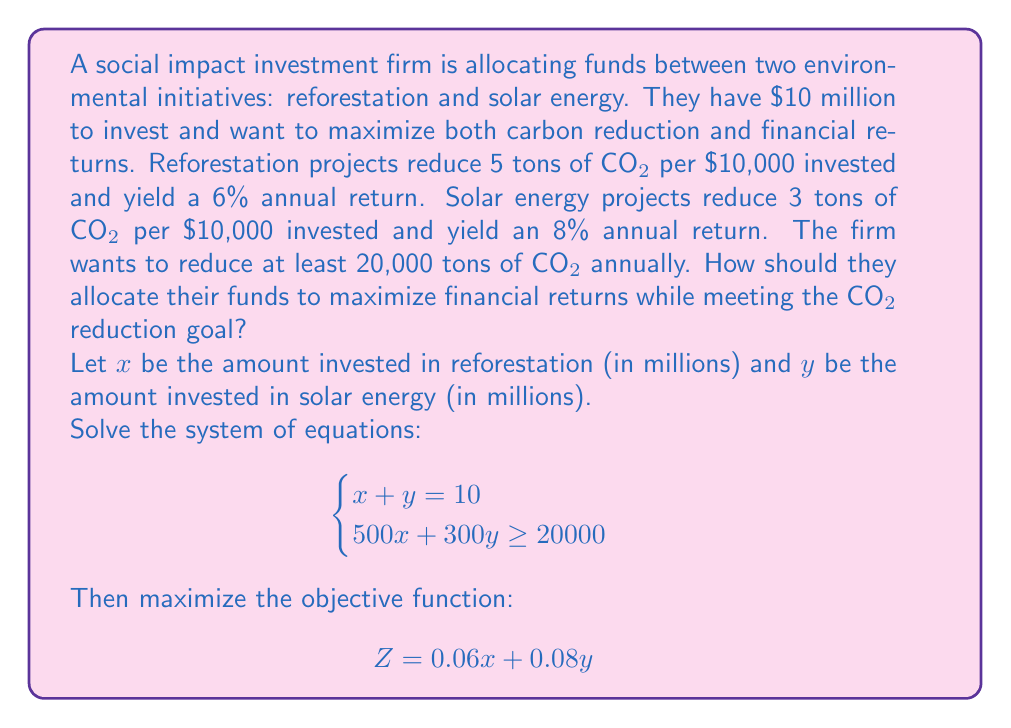Teach me how to tackle this problem. Let's approach this step-by-step:

1) First, we need to understand our constraints:
   - Total investment: $x + y = 10$
   - CO2 reduction: $500x + 300y \geq 20000$

2) We can graph these constraints:
   - The first equation is a straight line
   - The second inequality is a half-plane

3) The feasible region is the area that satisfies both constraints. The optimal solution will be at one of the corner points of this region.

4) To find the corner points, we solve the system of equations:
   $$\begin{cases}
   x + y = 10 \\
   500x + 300y = 20000
   \end{cases}$$

5) Multiply the first equation by 300:
   $$\begin{cases}
   300x + 300y = 3000 \\
   500x + 300y = 20000
   \end{cases}$$

6) Subtract the first equation from the second:
   $$200x = 17000$$
   $$x = 85/2 = 42.5$$

7) Substitute this value of $x$ into $x + y = 10$:
   $$42.5 + y = 10$$
   $$y = -32.5$$

8) However, $y$ cannot be negative. This means the optimal solution is at the intersection of $x + y = 10$ and $y = 0$, i.e., $(10, 0)$.

9) The other corner point is $(0, 10)$, but this doesn't satisfy the CO2 reduction constraint.

10) Therefore, the optimal solution is to invest all $10 million in reforestation.

11) We can verify the returns:
    $Z = 0.06(10) + 0.08(0) = 0.6$

This means a 6% return on the total investment, or $600,000 annually.
Answer: Invest $10 million in reforestation for a $600,000 annual return. 